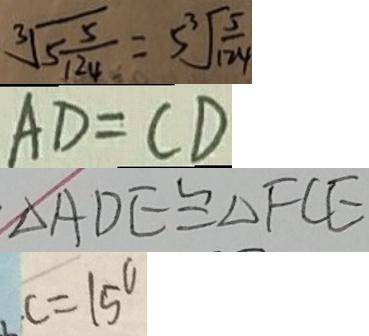<formula> <loc_0><loc_0><loc_500><loc_500>\sqrt [ 3 ] { 5 \frac { 5 } { 1 2 4 } } = 5 \sqrt [ 3 ] { \frac { 5 } { 1 2 4 } } 
 A D = C D 
 \Delta A D E \cong \Delta F C E 
 c = 1 5 ^ { \circ }</formula> 